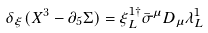<formula> <loc_0><loc_0><loc_500><loc_500>\delta _ { \xi } ( X ^ { 3 } - \partial _ { 5 } \Sigma ) = \xi ^ { 1 \dagger } _ { L } \bar { \sigma } ^ { \mu } D _ { \mu } \lambda ^ { 1 } _ { L }</formula> 